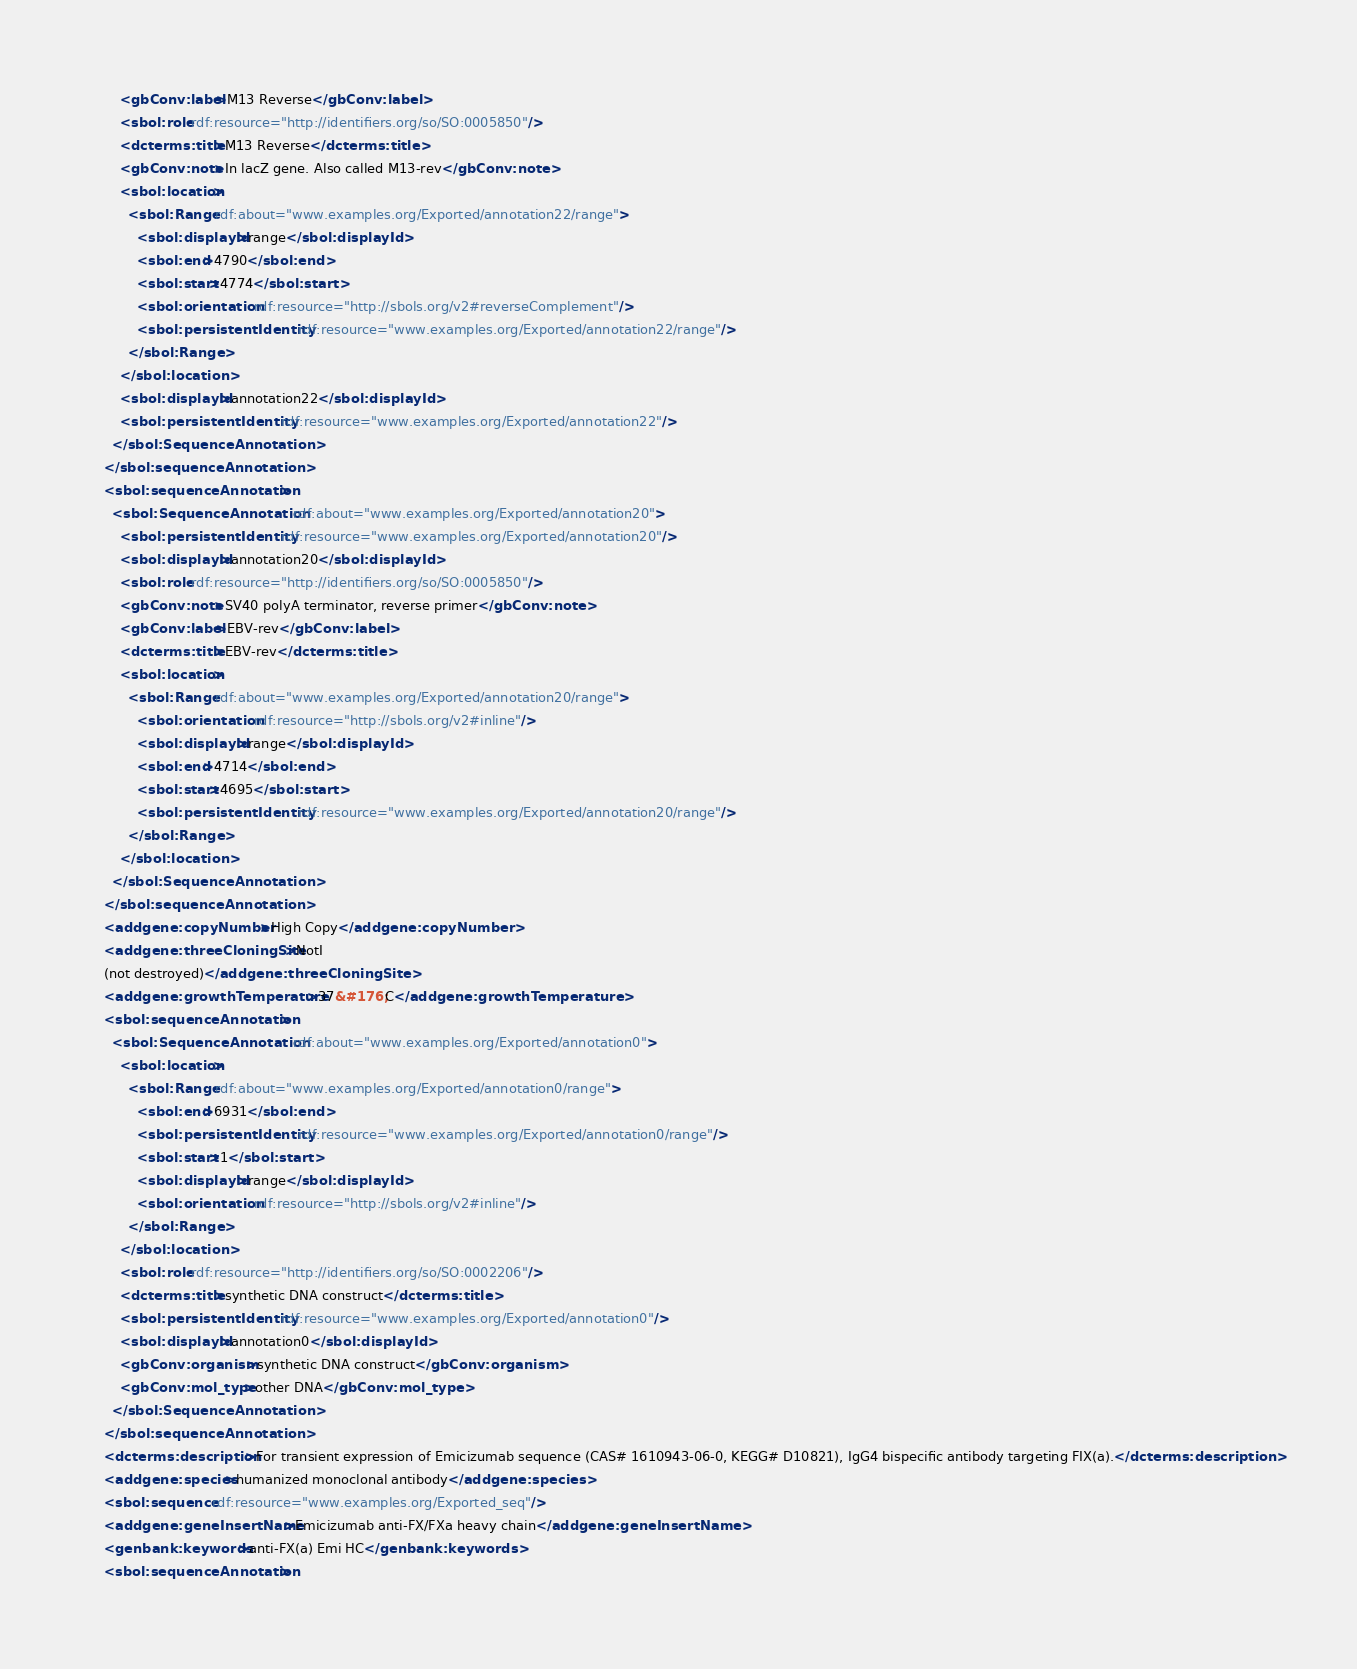Convert code to text. <code><loc_0><loc_0><loc_500><loc_500><_XML_>        <gbConv:label>M13 Reverse</gbConv:label>
        <sbol:role rdf:resource="http://identifiers.org/so/SO:0005850"/>
        <dcterms:title>M13 Reverse</dcterms:title>
        <gbConv:note>In lacZ gene. Also called M13-rev</gbConv:note>
        <sbol:location>
          <sbol:Range rdf:about="www.examples.org/Exported/annotation22/range">
            <sbol:displayId>range</sbol:displayId>
            <sbol:end>4790</sbol:end>
            <sbol:start>4774</sbol:start>
            <sbol:orientation rdf:resource="http://sbols.org/v2#reverseComplement"/>
            <sbol:persistentIdentity rdf:resource="www.examples.org/Exported/annotation22/range"/>
          </sbol:Range>
        </sbol:location>
        <sbol:displayId>annotation22</sbol:displayId>
        <sbol:persistentIdentity rdf:resource="www.examples.org/Exported/annotation22"/>
      </sbol:SequenceAnnotation>
    </sbol:sequenceAnnotation>
    <sbol:sequenceAnnotation>
      <sbol:SequenceAnnotation rdf:about="www.examples.org/Exported/annotation20">
        <sbol:persistentIdentity rdf:resource="www.examples.org/Exported/annotation20"/>
        <sbol:displayId>annotation20</sbol:displayId>
        <sbol:role rdf:resource="http://identifiers.org/so/SO:0005850"/>
        <gbConv:note>SV40 polyA terminator, reverse primer</gbConv:note>
        <gbConv:label>EBV-rev</gbConv:label>
        <dcterms:title>EBV-rev</dcterms:title>
        <sbol:location>
          <sbol:Range rdf:about="www.examples.org/Exported/annotation20/range">
            <sbol:orientation rdf:resource="http://sbols.org/v2#inline"/>
            <sbol:displayId>range</sbol:displayId>
            <sbol:end>4714</sbol:end>
            <sbol:start>4695</sbol:start>
            <sbol:persistentIdentity rdf:resource="www.examples.org/Exported/annotation20/range"/>
          </sbol:Range>
        </sbol:location>
      </sbol:SequenceAnnotation>
    </sbol:sequenceAnnotation>
    <addgene:copyNumber>High Copy</addgene:copyNumber>
    <addgene:threeCloningSite>NotI
    (not destroyed)</addgene:threeCloningSite>
    <addgene:growthTemperature>37&#176;C</addgene:growthTemperature>
    <sbol:sequenceAnnotation>
      <sbol:SequenceAnnotation rdf:about="www.examples.org/Exported/annotation0">
        <sbol:location>
          <sbol:Range rdf:about="www.examples.org/Exported/annotation0/range">
            <sbol:end>6931</sbol:end>
            <sbol:persistentIdentity rdf:resource="www.examples.org/Exported/annotation0/range"/>
            <sbol:start>1</sbol:start>
            <sbol:displayId>range</sbol:displayId>
            <sbol:orientation rdf:resource="http://sbols.org/v2#inline"/>
          </sbol:Range>
        </sbol:location>
        <sbol:role rdf:resource="http://identifiers.org/so/SO:0002206"/>
        <dcterms:title>synthetic DNA construct</dcterms:title>
        <sbol:persistentIdentity rdf:resource="www.examples.org/Exported/annotation0"/>
        <sbol:displayId>annotation0</sbol:displayId>
        <gbConv:organism>synthetic DNA construct</gbConv:organism>
        <gbConv:mol_type>other DNA</gbConv:mol_type>
      </sbol:SequenceAnnotation>
    </sbol:sequenceAnnotation>
    <dcterms:description>For transient expression of Emicizumab sequence (CAS# 1610943-06-0, KEGG# D10821), IgG4 bispecific antibody targeting FIX(a).</dcterms:description>
    <addgene:species>humanized monoclonal antibody</addgene:species>
    <sbol:sequence rdf:resource="www.examples.org/Exported_seq"/>
    <addgene:geneInsertName>Emicizumab anti-FX/FXa heavy chain</addgene:geneInsertName>
    <genbank:keywords>anti-FX(a) Emi HC</genbank:keywords>
    <sbol:sequenceAnnotation></code> 